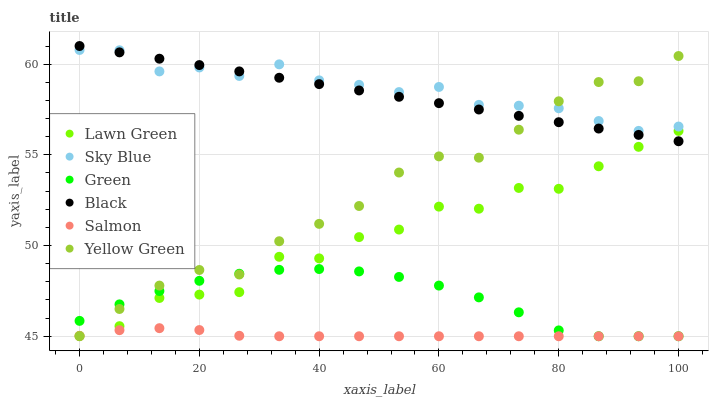Does Salmon have the minimum area under the curve?
Answer yes or no. Yes. Does Sky Blue have the maximum area under the curve?
Answer yes or no. Yes. Does Yellow Green have the minimum area under the curve?
Answer yes or no. No. Does Yellow Green have the maximum area under the curve?
Answer yes or no. No. Is Black the smoothest?
Answer yes or no. Yes. Is Lawn Green the roughest?
Answer yes or no. Yes. Is Yellow Green the smoothest?
Answer yes or no. No. Is Yellow Green the roughest?
Answer yes or no. No. Does Yellow Green have the lowest value?
Answer yes or no. Yes. Does Sky Blue have the lowest value?
Answer yes or no. No. Does Black have the highest value?
Answer yes or no. Yes. Does Yellow Green have the highest value?
Answer yes or no. No. Is Lawn Green less than Sky Blue?
Answer yes or no. Yes. Is Sky Blue greater than Lawn Green?
Answer yes or no. Yes. Does Yellow Green intersect Lawn Green?
Answer yes or no. Yes. Is Yellow Green less than Lawn Green?
Answer yes or no. No. Is Yellow Green greater than Lawn Green?
Answer yes or no. No. Does Lawn Green intersect Sky Blue?
Answer yes or no. No. 